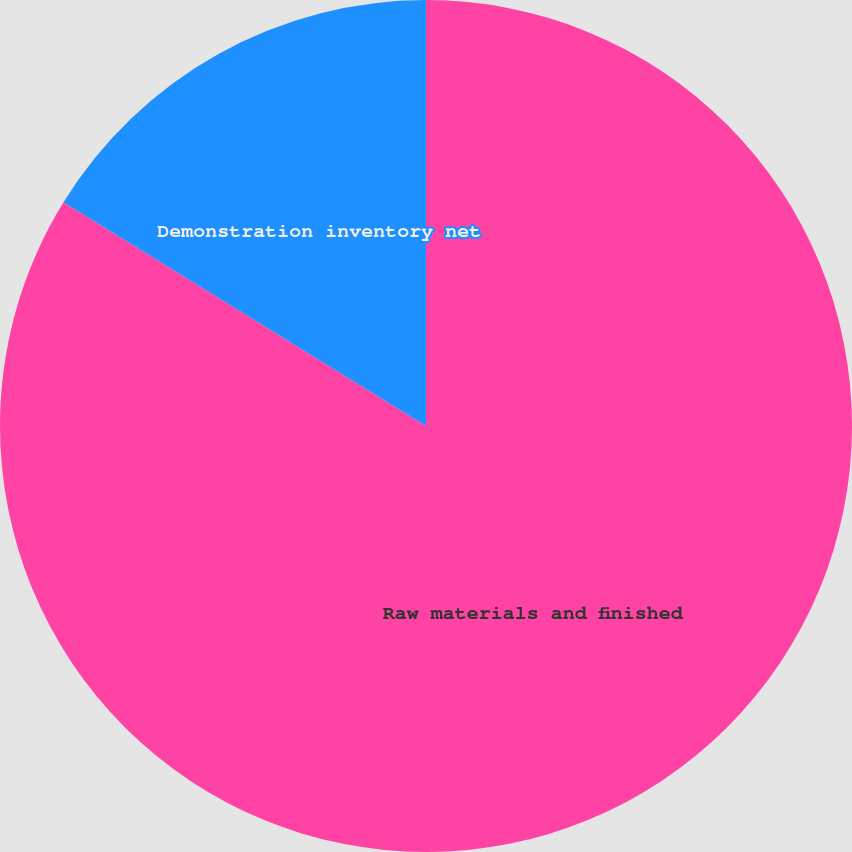Convert chart to OTSL. <chart><loc_0><loc_0><loc_500><loc_500><pie_chart><fcel>Raw materials and finished<fcel>Demonstration inventory net<nl><fcel>83.8%<fcel>16.2%<nl></chart> 